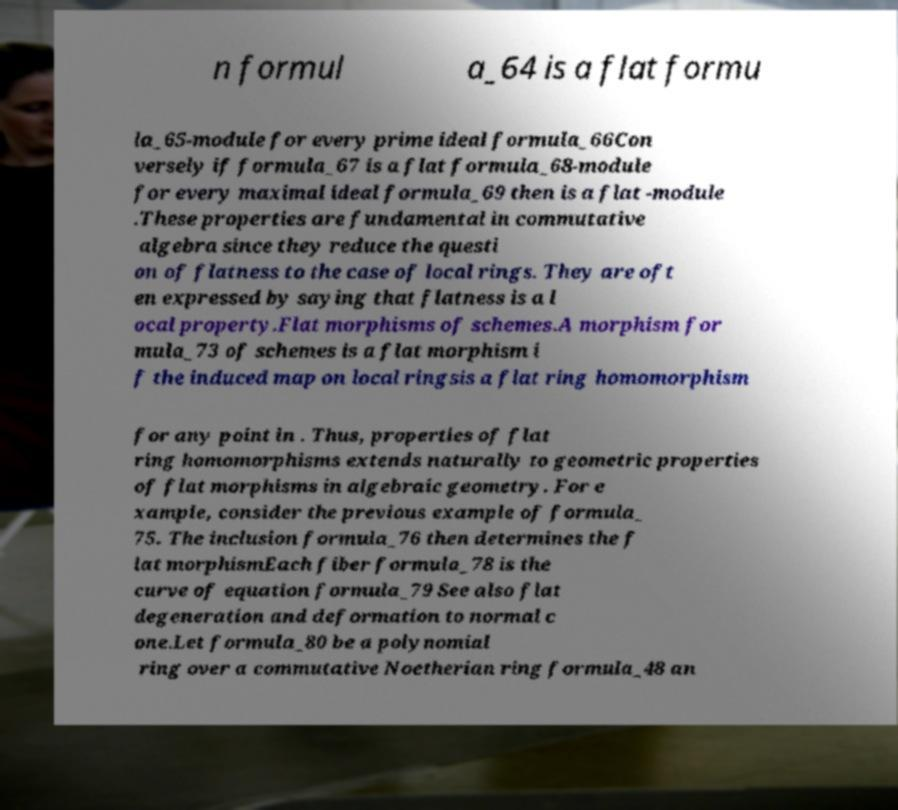What messages or text are displayed in this image? I need them in a readable, typed format. n formul a_64 is a flat formu la_65-module for every prime ideal formula_66Con versely if formula_67 is a flat formula_68-module for every maximal ideal formula_69 then is a flat -module .These properties are fundamental in commutative algebra since they reduce the questi on of flatness to the case of local rings. They are oft en expressed by saying that flatness is a l ocal property.Flat morphisms of schemes.A morphism for mula_73 of schemes is a flat morphism i f the induced map on local ringsis a flat ring homomorphism for any point in . Thus, properties of flat ring homomorphisms extends naturally to geometric properties of flat morphisms in algebraic geometry. For e xample, consider the previous example of formula_ 75. The inclusion formula_76 then determines the f lat morphismEach fiber formula_78 is the curve of equation formula_79 See also flat degeneration and deformation to normal c one.Let formula_80 be a polynomial ring over a commutative Noetherian ring formula_48 an 